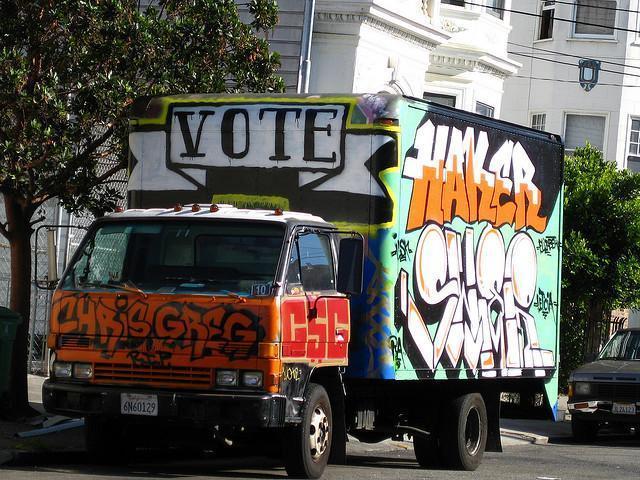How many trucks are there?
Give a very brief answer. 1. How many people are not holding a surfboard?
Give a very brief answer. 0. 